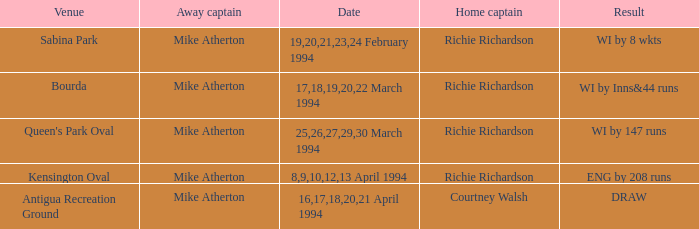Which Home Captain has Eng by 208 runs? Richie Richardson. 